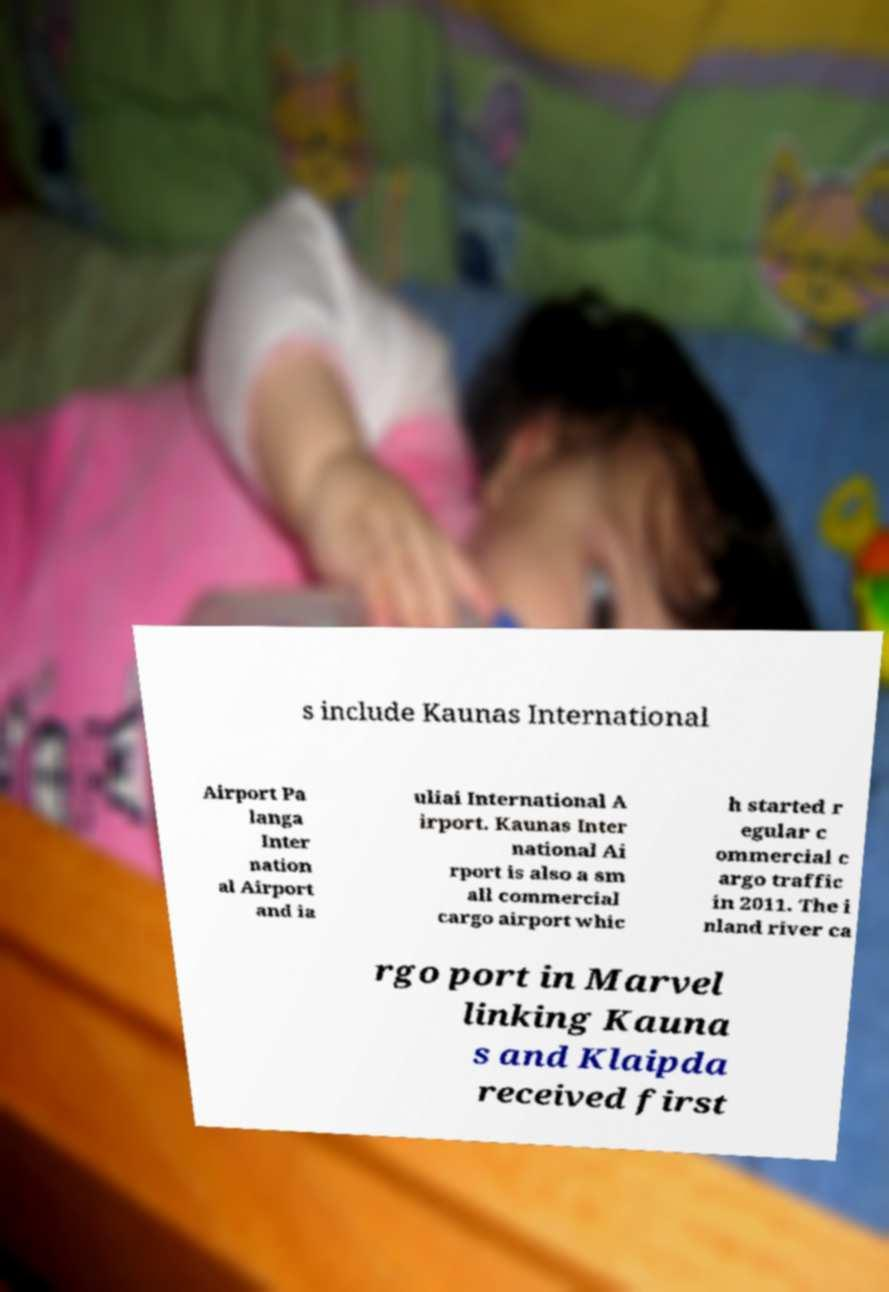Could you extract and type out the text from this image? s include Kaunas International Airport Pa langa Inter nation al Airport and ia uliai International A irport. Kaunas Inter national Ai rport is also a sm all commercial cargo airport whic h started r egular c ommercial c argo traffic in 2011. The i nland river ca rgo port in Marvel linking Kauna s and Klaipda received first 